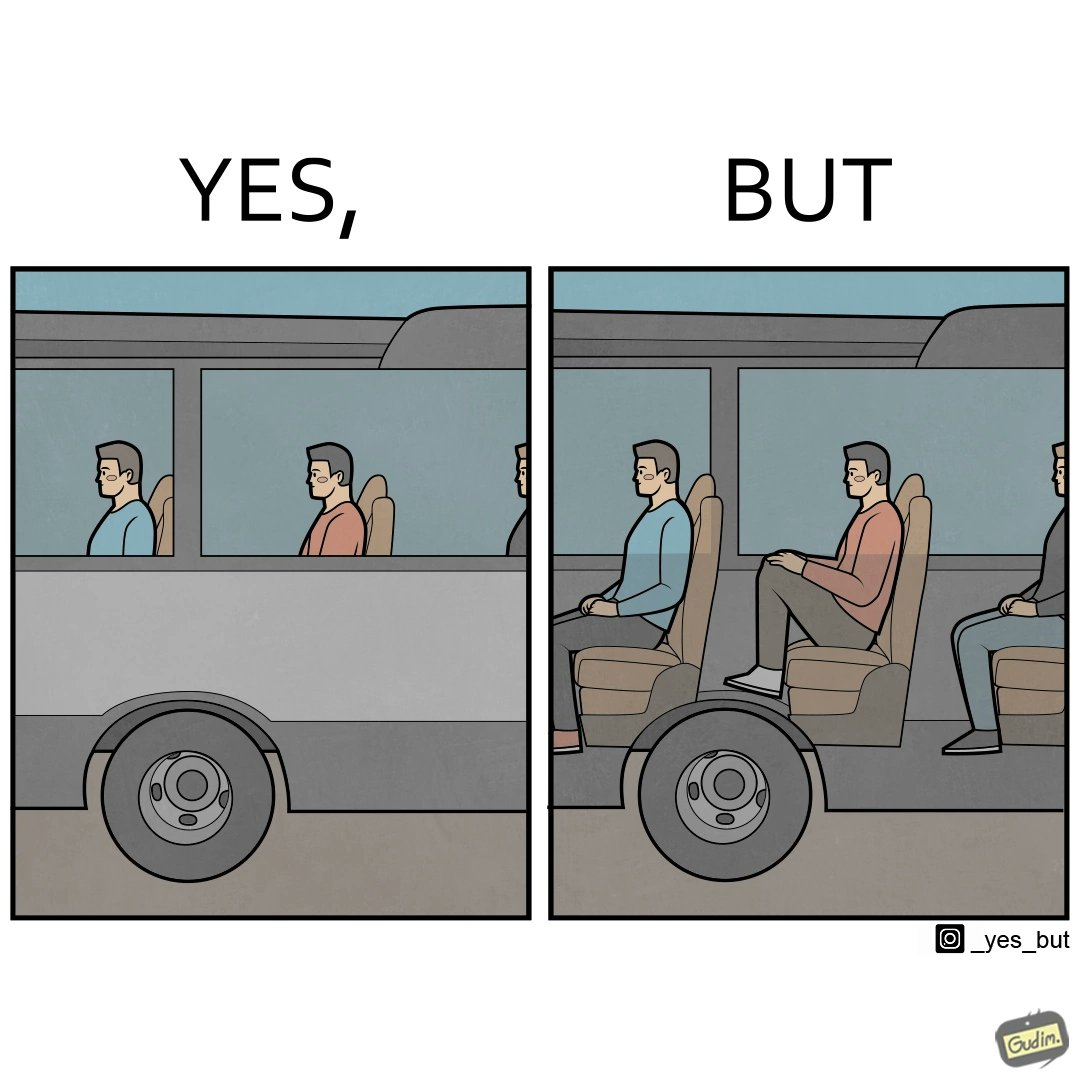Explain the humor or irony in this image. the irony in this image is that the seat right above a bus' wheels is the most uncomfortable one. 